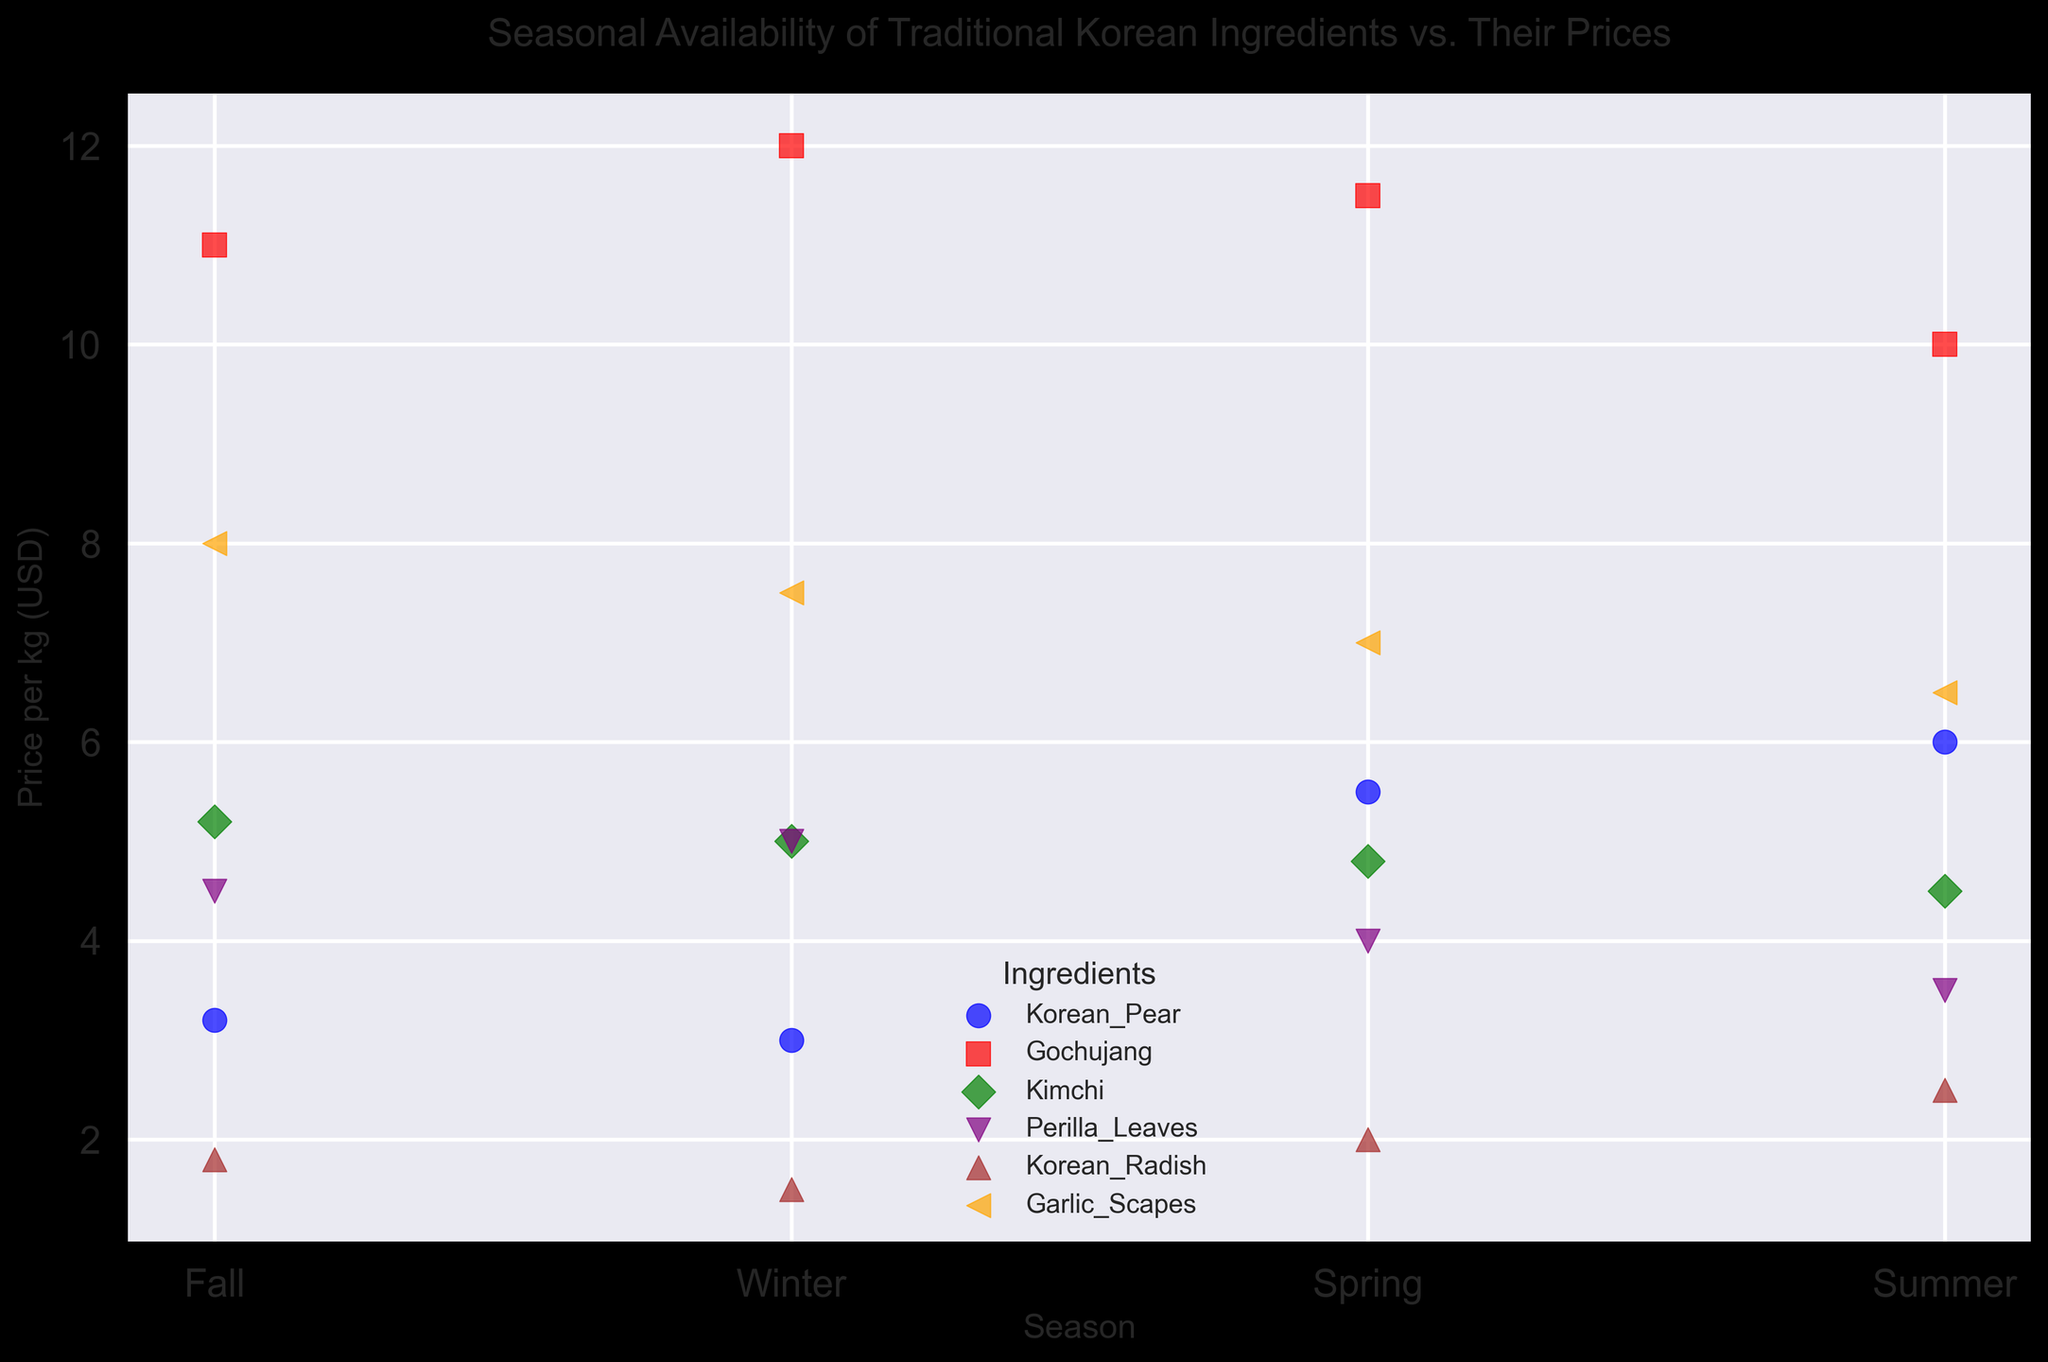What's the lowest price of Korean Pear and in which season does it occur? The plot shows the price of Korean Pear across different seasons. By looking at the scatter points for Korean Pear, indicated by blue circles, we can see that the lowest price is $3.0 per kg, which occurs in Winter.
Answer: $3.0, Winter Which ingredient has the highest price per kg in Summer? In Summer, look for the highest position among the various markers. The highest point corresponds to Gochujang, indicated by the red square, with a price of $10.0 per kg.
Answer: Gochujang Compare the prices of Kimchi and Perilla Leaves in Winter. Which one is more expensive? In Winter, find the green diamond for Kimchi and the purple triangle for Perilla Leaves. Kimchi is priced at $5.0 per kg, while Perilla Leaves are priced at $5.0 per kg. Therefore, they are equally priced.
Answer: Equally priced What is the average price of Korean Radish across all seasons? To calculate the average, sum up the prices of Korean Radish in each season and divide by the number of seasons. The prices are $1.5 (Winter), $2.0 (Spring), $2.5 (Summer), and $1.8 (Fall). Sum = 1.5 + 2.0 + 2.5 + 1.8 = 7.8. Average = 7.8 / 4 = 1.95.
Answer: $1.95 Is the price of Garlic Scapes higher in Fall or Winter? Compare the orange left-pointing triangles for Garlic Scapes in Fall and Winter. In Fall, the price is $8.0 per kg, and in Winter, it is $7.5 per kg. Fall has a higher price.
Answer: Fall What is the most expensive ingredient in Fall? Identify the highest scatter point among all ingredients in Fall. The highest point corresponds to Garlic Scapes (orange left-pointing triangle) with a price of $8.0 per kg.
Answer: Garlic Scapes Compare the prices of Gochujang and Kimchi in Spring. Which one is cheaper? Locate the red square for Gochujang and the green diamond for Kimchi in Spring. Gochujang is priced at $11.5 per kg, while Kimchi is priced at $4.8 per kg. Therefore, Kimchi is cheaper.
Answer: Kimchi During which season does Korean Pear have the highest price? Find the blue circles for Korean Pear across all seasons and identify the highest one. The highest price is $6.0 per kg in Summer.
Answer: Summer 